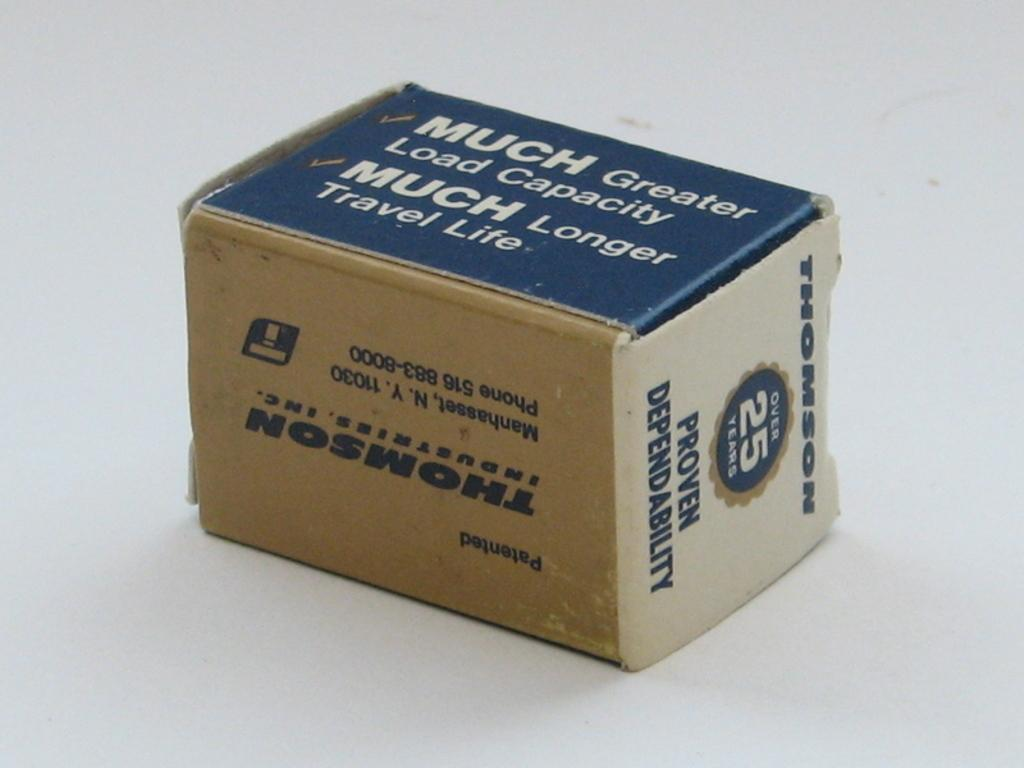<image>
Render a clear and concise summary of the photo. The company shown claims they have proven dependability. 